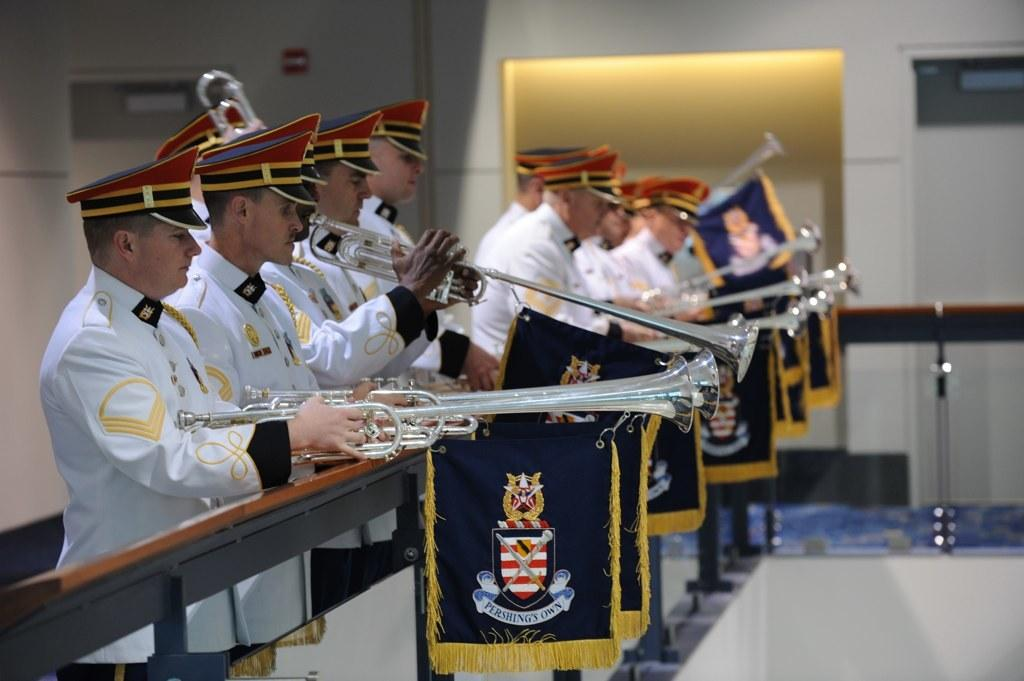What are the people in the image wearing? The people in the image are wearing costumes. What are some of the people holding in the image? Some of the people are holding trumpets. What is one person doing with a trumpet in the image? One person is playing a trumpet. What can be seen in the image besides the people and their instruments? There are flags, a wall, and a door in the background of the image. What type of sand can be seen on the ground in the image? There is no sand visible in the image; it appears to be a paved or indoor setting. 